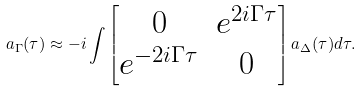<formula> <loc_0><loc_0><loc_500><loc_500>a _ { \Gamma } ( \tau ) \approx - i \int \begin{bmatrix} 0 & e ^ { 2 i \Gamma \tau } \\ e ^ { - 2 i \Gamma \tau } & 0 \\ \end{bmatrix} a _ { \Delta } ( \tau ) d \tau .</formula> 